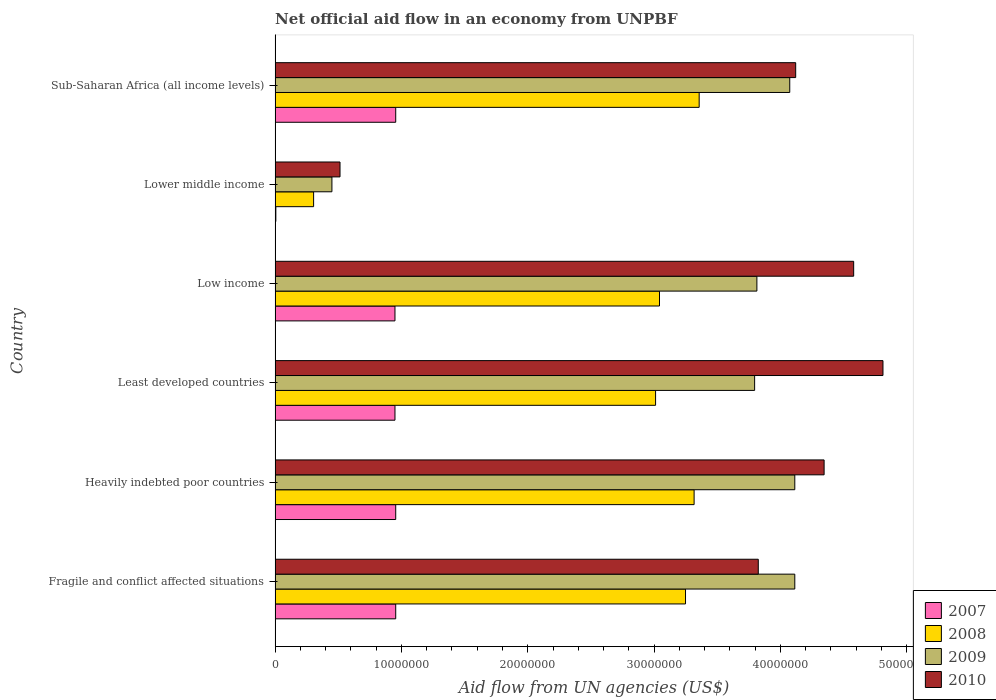Are the number of bars per tick equal to the number of legend labels?
Offer a very short reply. Yes. How many bars are there on the 6th tick from the bottom?
Keep it short and to the point. 4. What is the label of the 3rd group of bars from the top?
Provide a succinct answer. Low income. What is the net official aid flow in 2008 in Low income?
Make the answer very short. 3.04e+07. Across all countries, what is the maximum net official aid flow in 2008?
Give a very brief answer. 3.36e+07. Across all countries, what is the minimum net official aid flow in 2008?
Offer a very short reply. 3.05e+06. In which country was the net official aid flow in 2010 maximum?
Keep it short and to the point. Least developed countries. In which country was the net official aid flow in 2007 minimum?
Offer a terse response. Lower middle income. What is the total net official aid flow in 2009 in the graph?
Give a very brief answer. 2.04e+08. What is the difference between the net official aid flow in 2008 in Lower middle income and that in Sub-Saharan Africa (all income levels)?
Your answer should be compact. -3.05e+07. What is the difference between the net official aid flow in 2009 in Sub-Saharan Africa (all income levels) and the net official aid flow in 2008 in Low income?
Keep it short and to the point. 1.03e+07. What is the average net official aid flow in 2009 per country?
Offer a very short reply. 3.39e+07. What is the difference between the net official aid flow in 2010 and net official aid flow in 2007 in Low income?
Provide a succinct answer. 3.63e+07. In how many countries, is the net official aid flow in 2009 greater than 24000000 US$?
Provide a succinct answer. 5. What is the ratio of the net official aid flow in 2007 in Fragile and conflict affected situations to that in Low income?
Provide a succinct answer. 1.01. Is the net official aid flow in 2008 in Fragile and conflict affected situations less than that in Sub-Saharan Africa (all income levels)?
Give a very brief answer. Yes. Is the difference between the net official aid flow in 2010 in Heavily indebted poor countries and Sub-Saharan Africa (all income levels) greater than the difference between the net official aid flow in 2007 in Heavily indebted poor countries and Sub-Saharan Africa (all income levels)?
Your answer should be compact. Yes. What is the difference between the highest and the lowest net official aid flow in 2008?
Your answer should be compact. 3.05e+07. In how many countries, is the net official aid flow in 2007 greater than the average net official aid flow in 2007 taken over all countries?
Give a very brief answer. 5. What is the difference between two consecutive major ticks on the X-axis?
Keep it short and to the point. 1.00e+07. Are the values on the major ticks of X-axis written in scientific E-notation?
Make the answer very short. No. Where does the legend appear in the graph?
Your response must be concise. Bottom right. How many legend labels are there?
Ensure brevity in your answer.  4. How are the legend labels stacked?
Offer a very short reply. Vertical. What is the title of the graph?
Provide a succinct answer. Net official aid flow in an economy from UNPBF. What is the label or title of the X-axis?
Ensure brevity in your answer.  Aid flow from UN agencies (US$). What is the label or title of the Y-axis?
Ensure brevity in your answer.  Country. What is the Aid flow from UN agencies (US$) in 2007 in Fragile and conflict affected situations?
Provide a short and direct response. 9.55e+06. What is the Aid flow from UN agencies (US$) in 2008 in Fragile and conflict affected situations?
Keep it short and to the point. 3.25e+07. What is the Aid flow from UN agencies (US$) of 2009 in Fragile and conflict affected situations?
Ensure brevity in your answer.  4.11e+07. What is the Aid flow from UN agencies (US$) in 2010 in Fragile and conflict affected situations?
Provide a short and direct response. 3.82e+07. What is the Aid flow from UN agencies (US$) in 2007 in Heavily indebted poor countries?
Keep it short and to the point. 9.55e+06. What is the Aid flow from UN agencies (US$) in 2008 in Heavily indebted poor countries?
Make the answer very short. 3.32e+07. What is the Aid flow from UN agencies (US$) in 2009 in Heavily indebted poor countries?
Provide a short and direct response. 4.11e+07. What is the Aid flow from UN agencies (US$) of 2010 in Heavily indebted poor countries?
Keep it short and to the point. 4.35e+07. What is the Aid flow from UN agencies (US$) of 2007 in Least developed countries?
Ensure brevity in your answer.  9.49e+06. What is the Aid flow from UN agencies (US$) in 2008 in Least developed countries?
Your response must be concise. 3.01e+07. What is the Aid flow from UN agencies (US$) in 2009 in Least developed countries?
Keep it short and to the point. 3.80e+07. What is the Aid flow from UN agencies (US$) in 2010 in Least developed countries?
Your answer should be compact. 4.81e+07. What is the Aid flow from UN agencies (US$) in 2007 in Low income?
Keep it short and to the point. 9.49e+06. What is the Aid flow from UN agencies (US$) in 2008 in Low income?
Your response must be concise. 3.04e+07. What is the Aid flow from UN agencies (US$) in 2009 in Low income?
Make the answer very short. 3.81e+07. What is the Aid flow from UN agencies (US$) of 2010 in Low income?
Ensure brevity in your answer.  4.58e+07. What is the Aid flow from UN agencies (US$) in 2008 in Lower middle income?
Give a very brief answer. 3.05e+06. What is the Aid flow from UN agencies (US$) in 2009 in Lower middle income?
Offer a very short reply. 4.50e+06. What is the Aid flow from UN agencies (US$) in 2010 in Lower middle income?
Your response must be concise. 5.14e+06. What is the Aid flow from UN agencies (US$) of 2007 in Sub-Saharan Africa (all income levels)?
Ensure brevity in your answer.  9.55e+06. What is the Aid flow from UN agencies (US$) in 2008 in Sub-Saharan Africa (all income levels)?
Offer a very short reply. 3.36e+07. What is the Aid flow from UN agencies (US$) in 2009 in Sub-Saharan Africa (all income levels)?
Your answer should be compact. 4.07e+07. What is the Aid flow from UN agencies (US$) in 2010 in Sub-Saharan Africa (all income levels)?
Ensure brevity in your answer.  4.12e+07. Across all countries, what is the maximum Aid flow from UN agencies (US$) of 2007?
Offer a very short reply. 9.55e+06. Across all countries, what is the maximum Aid flow from UN agencies (US$) in 2008?
Offer a very short reply. 3.36e+07. Across all countries, what is the maximum Aid flow from UN agencies (US$) in 2009?
Give a very brief answer. 4.11e+07. Across all countries, what is the maximum Aid flow from UN agencies (US$) in 2010?
Your answer should be very brief. 4.81e+07. Across all countries, what is the minimum Aid flow from UN agencies (US$) in 2008?
Ensure brevity in your answer.  3.05e+06. Across all countries, what is the minimum Aid flow from UN agencies (US$) of 2009?
Keep it short and to the point. 4.50e+06. Across all countries, what is the minimum Aid flow from UN agencies (US$) of 2010?
Provide a short and direct response. 5.14e+06. What is the total Aid flow from UN agencies (US$) of 2007 in the graph?
Make the answer very short. 4.77e+07. What is the total Aid flow from UN agencies (US$) of 2008 in the graph?
Your response must be concise. 1.63e+08. What is the total Aid flow from UN agencies (US$) in 2009 in the graph?
Offer a terse response. 2.04e+08. What is the total Aid flow from UN agencies (US$) of 2010 in the graph?
Provide a succinct answer. 2.22e+08. What is the difference between the Aid flow from UN agencies (US$) in 2007 in Fragile and conflict affected situations and that in Heavily indebted poor countries?
Provide a short and direct response. 0. What is the difference between the Aid flow from UN agencies (US$) of 2008 in Fragile and conflict affected situations and that in Heavily indebted poor countries?
Give a very brief answer. -6.80e+05. What is the difference between the Aid flow from UN agencies (US$) in 2010 in Fragile and conflict affected situations and that in Heavily indebted poor countries?
Provide a short and direct response. -5.21e+06. What is the difference between the Aid flow from UN agencies (US$) in 2007 in Fragile and conflict affected situations and that in Least developed countries?
Your answer should be compact. 6.00e+04. What is the difference between the Aid flow from UN agencies (US$) in 2008 in Fragile and conflict affected situations and that in Least developed countries?
Offer a terse response. 2.37e+06. What is the difference between the Aid flow from UN agencies (US$) in 2009 in Fragile and conflict affected situations and that in Least developed countries?
Your answer should be compact. 3.18e+06. What is the difference between the Aid flow from UN agencies (US$) in 2010 in Fragile and conflict affected situations and that in Least developed countries?
Keep it short and to the point. -9.87e+06. What is the difference between the Aid flow from UN agencies (US$) in 2008 in Fragile and conflict affected situations and that in Low income?
Your answer should be compact. 2.06e+06. What is the difference between the Aid flow from UN agencies (US$) in 2010 in Fragile and conflict affected situations and that in Low income?
Offer a terse response. -7.55e+06. What is the difference between the Aid flow from UN agencies (US$) in 2007 in Fragile and conflict affected situations and that in Lower middle income?
Offer a terse response. 9.49e+06. What is the difference between the Aid flow from UN agencies (US$) in 2008 in Fragile and conflict affected situations and that in Lower middle income?
Give a very brief answer. 2.94e+07. What is the difference between the Aid flow from UN agencies (US$) in 2009 in Fragile and conflict affected situations and that in Lower middle income?
Give a very brief answer. 3.66e+07. What is the difference between the Aid flow from UN agencies (US$) of 2010 in Fragile and conflict affected situations and that in Lower middle income?
Provide a short and direct response. 3.31e+07. What is the difference between the Aid flow from UN agencies (US$) of 2007 in Fragile and conflict affected situations and that in Sub-Saharan Africa (all income levels)?
Ensure brevity in your answer.  0. What is the difference between the Aid flow from UN agencies (US$) of 2008 in Fragile and conflict affected situations and that in Sub-Saharan Africa (all income levels)?
Your response must be concise. -1.08e+06. What is the difference between the Aid flow from UN agencies (US$) in 2010 in Fragile and conflict affected situations and that in Sub-Saharan Africa (all income levels)?
Keep it short and to the point. -2.96e+06. What is the difference between the Aid flow from UN agencies (US$) in 2008 in Heavily indebted poor countries and that in Least developed countries?
Ensure brevity in your answer.  3.05e+06. What is the difference between the Aid flow from UN agencies (US$) in 2009 in Heavily indebted poor countries and that in Least developed countries?
Your response must be concise. 3.18e+06. What is the difference between the Aid flow from UN agencies (US$) in 2010 in Heavily indebted poor countries and that in Least developed countries?
Provide a succinct answer. -4.66e+06. What is the difference between the Aid flow from UN agencies (US$) of 2008 in Heavily indebted poor countries and that in Low income?
Offer a terse response. 2.74e+06. What is the difference between the Aid flow from UN agencies (US$) in 2010 in Heavily indebted poor countries and that in Low income?
Make the answer very short. -2.34e+06. What is the difference between the Aid flow from UN agencies (US$) in 2007 in Heavily indebted poor countries and that in Lower middle income?
Provide a succinct answer. 9.49e+06. What is the difference between the Aid flow from UN agencies (US$) in 2008 in Heavily indebted poor countries and that in Lower middle income?
Your answer should be compact. 3.01e+07. What is the difference between the Aid flow from UN agencies (US$) in 2009 in Heavily indebted poor countries and that in Lower middle income?
Ensure brevity in your answer.  3.66e+07. What is the difference between the Aid flow from UN agencies (US$) in 2010 in Heavily indebted poor countries and that in Lower middle income?
Your response must be concise. 3.83e+07. What is the difference between the Aid flow from UN agencies (US$) in 2007 in Heavily indebted poor countries and that in Sub-Saharan Africa (all income levels)?
Provide a short and direct response. 0. What is the difference between the Aid flow from UN agencies (US$) of 2008 in Heavily indebted poor countries and that in Sub-Saharan Africa (all income levels)?
Your response must be concise. -4.00e+05. What is the difference between the Aid flow from UN agencies (US$) of 2009 in Heavily indebted poor countries and that in Sub-Saharan Africa (all income levels)?
Keep it short and to the point. 4.00e+05. What is the difference between the Aid flow from UN agencies (US$) of 2010 in Heavily indebted poor countries and that in Sub-Saharan Africa (all income levels)?
Offer a very short reply. 2.25e+06. What is the difference between the Aid flow from UN agencies (US$) of 2008 in Least developed countries and that in Low income?
Your answer should be compact. -3.10e+05. What is the difference between the Aid flow from UN agencies (US$) of 2009 in Least developed countries and that in Low income?
Provide a succinct answer. -1.80e+05. What is the difference between the Aid flow from UN agencies (US$) in 2010 in Least developed countries and that in Low income?
Your response must be concise. 2.32e+06. What is the difference between the Aid flow from UN agencies (US$) in 2007 in Least developed countries and that in Lower middle income?
Ensure brevity in your answer.  9.43e+06. What is the difference between the Aid flow from UN agencies (US$) of 2008 in Least developed countries and that in Lower middle income?
Ensure brevity in your answer.  2.71e+07. What is the difference between the Aid flow from UN agencies (US$) in 2009 in Least developed countries and that in Lower middle income?
Offer a terse response. 3.35e+07. What is the difference between the Aid flow from UN agencies (US$) in 2010 in Least developed countries and that in Lower middle income?
Offer a terse response. 4.30e+07. What is the difference between the Aid flow from UN agencies (US$) in 2008 in Least developed countries and that in Sub-Saharan Africa (all income levels)?
Offer a very short reply. -3.45e+06. What is the difference between the Aid flow from UN agencies (US$) in 2009 in Least developed countries and that in Sub-Saharan Africa (all income levels)?
Ensure brevity in your answer.  -2.78e+06. What is the difference between the Aid flow from UN agencies (US$) of 2010 in Least developed countries and that in Sub-Saharan Africa (all income levels)?
Your answer should be very brief. 6.91e+06. What is the difference between the Aid flow from UN agencies (US$) of 2007 in Low income and that in Lower middle income?
Offer a very short reply. 9.43e+06. What is the difference between the Aid flow from UN agencies (US$) of 2008 in Low income and that in Lower middle income?
Provide a short and direct response. 2.74e+07. What is the difference between the Aid flow from UN agencies (US$) in 2009 in Low income and that in Lower middle income?
Offer a terse response. 3.36e+07. What is the difference between the Aid flow from UN agencies (US$) in 2010 in Low income and that in Lower middle income?
Make the answer very short. 4.07e+07. What is the difference between the Aid flow from UN agencies (US$) in 2008 in Low income and that in Sub-Saharan Africa (all income levels)?
Your answer should be very brief. -3.14e+06. What is the difference between the Aid flow from UN agencies (US$) in 2009 in Low income and that in Sub-Saharan Africa (all income levels)?
Your answer should be compact. -2.60e+06. What is the difference between the Aid flow from UN agencies (US$) in 2010 in Low income and that in Sub-Saharan Africa (all income levels)?
Provide a succinct answer. 4.59e+06. What is the difference between the Aid flow from UN agencies (US$) in 2007 in Lower middle income and that in Sub-Saharan Africa (all income levels)?
Your answer should be compact. -9.49e+06. What is the difference between the Aid flow from UN agencies (US$) in 2008 in Lower middle income and that in Sub-Saharan Africa (all income levels)?
Keep it short and to the point. -3.05e+07. What is the difference between the Aid flow from UN agencies (US$) of 2009 in Lower middle income and that in Sub-Saharan Africa (all income levels)?
Make the answer very short. -3.62e+07. What is the difference between the Aid flow from UN agencies (US$) of 2010 in Lower middle income and that in Sub-Saharan Africa (all income levels)?
Your response must be concise. -3.61e+07. What is the difference between the Aid flow from UN agencies (US$) of 2007 in Fragile and conflict affected situations and the Aid flow from UN agencies (US$) of 2008 in Heavily indebted poor countries?
Offer a very short reply. -2.36e+07. What is the difference between the Aid flow from UN agencies (US$) of 2007 in Fragile and conflict affected situations and the Aid flow from UN agencies (US$) of 2009 in Heavily indebted poor countries?
Give a very brief answer. -3.16e+07. What is the difference between the Aid flow from UN agencies (US$) in 2007 in Fragile and conflict affected situations and the Aid flow from UN agencies (US$) in 2010 in Heavily indebted poor countries?
Keep it short and to the point. -3.39e+07. What is the difference between the Aid flow from UN agencies (US$) in 2008 in Fragile and conflict affected situations and the Aid flow from UN agencies (US$) in 2009 in Heavily indebted poor countries?
Your response must be concise. -8.65e+06. What is the difference between the Aid flow from UN agencies (US$) of 2008 in Fragile and conflict affected situations and the Aid flow from UN agencies (US$) of 2010 in Heavily indebted poor countries?
Ensure brevity in your answer.  -1.10e+07. What is the difference between the Aid flow from UN agencies (US$) of 2009 in Fragile and conflict affected situations and the Aid flow from UN agencies (US$) of 2010 in Heavily indebted poor countries?
Your answer should be very brief. -2.32e+06. What is the difference between the Aid flow from UN agencies (US$) in 2007 in Fragile and conflict affected situations and the Aid flow from UN agencies (US$) in 2008 in Least developed countries?
Provide a succinct answer. -2.06e+07. What is the difference between the Aid flow from UN agencies (US$) in 2007 in Fragile and conflict affected situations and the Aid flow from UN agencies (US$) in 2009 in Least developed countries?
Your answer should be very brief. -2.84e+07. What is the difference between the Aid flow from UN agencies (US$) of 2007 in Fragile and conflict affected situations and the Aid flow from UN agencies (US$) of 2010 in Least developed countries?
Offer a terse response. -3.86e+07. What is the difference between the Aid flow from UN agencies (US$) of 2008 in Fragile and conflict affected situations and the Aid flow from UN agencies (US$) of 2009 in Least developed countries?
Offer a very short reply. -5.47e+06. What is the difference between the Aid flow from UN agencies (US$) of 2008 in Fragile and conflict affected situations and the Aid flow from UN agencies (US$) of 2010 in Least developed countries?
Keep it short and to the point. -1.56e+07. What is the difference between the Aid flow from UN agencies (US$) of 2009 in Fragile and conflict affected situations and the Aid flow from UN agencies (US$) of 2010 in Least developed countries?
Your response must be concise. -6.98e+06. What is the difference between the Aid flow from UN agencies (US$) of 2007 in Fragile and conflict affected situations and the Aid flow from UN agencies (US$) of 2008 in Low income?
Keep it short and to the point. -2.09e+07. What is the difference between the Aid flow from UN agencies (US$) of 2007 in Fragile and conflict affected situations and the Aid flow from UN agencies (US$) of 2009 in Low income?
Offer a terse response. -2.86e+07. What is the difference between the Aid flow from UN agencies (US$) in 2007 in Fragile and conflict affected situations and the Aid flow from UN agencies (US$) in 2010 in Low income?
Your answer should be very brief. -3.62e+07. What is the difference between the Aid flow from UN agencies (US$) of 2008 in Fragile and conflict affected situations and the Aid flow from UN agencies (US$) of 2009 in Low income?
Provide a short and direct response. -5.65e+06. What is the difference between the Aid flow from UN agencies (US$) of 2008 in Fragile and conflict affected situations and the Aid flow from UN agencies (US$) of 2010 in Low income?
Your answer should be compact. -1.33e+07. What is the difference between the Aid flow from UN agencies (US$) in 2009 in Fragile and conflict affected situations and the Aid flow from UN agencies (US$) in 2010 in Low income?
Ensure brevity in your answer.  -4.66e+06. What is the difference between the Aid flow from UN agencies (US$) in 2007 in Fragile and conflict affected situations and the Aid flow from UN agencies (US$) in 2008 in Lower middle income?
Keep it short and to the point. 6.50e+06. What is the difference between the Aid flow from UN agencies (US$) of 2007 in Fragile and conflict affected situations and the Aid flow from UN agencies (US$) of 2009 in Lower middle income?
Ensure brevity in your answer.  5.05e+06. What is the difference between the Aid flow from UN agencies (US$) in 2007 in Fragile and conflict affected situations and the Aid flow from UN agencies (US$) in 2010 in Lower middle income?
Keep it short and to the point. 4.41e+06. What is the difference between the Aid flow from UN agencies (US$) in 2008 in Fragile and conflict affected situations and the Aid flow from UN agencies (US$) in 2009 in Lower middle income?
Offer a terse response. 2.80e+07. What is the difference between the Aid flow from UN agencies (US$) of 2008 in Fragile and conflict affected situations and the Aid flow from UN agencies (US$) of 2010 in Lower middle income?
Keep it short and to the point. 2.74e+07. What is the difference between the Aid flow from UN agencies (US$) of 2009 in Fragile and conflict affected situations and the Aid flow from UN agencies (US$) of 2010 in Lower middle income?
Your answer should be very brief. 3.60e+07. What is the difference between the Aid flow from UN agencies (US$) of 2007 in Fragile and conflict affected situations and the Aid flow from UN agencies (US$) of 2008 in Sub-Saharan Africa (all income levels)?
Make the answer very short. -2.40e+07. What is the difference between the Aid flow from UN agencies (US$) in 2007 in Fragile and conflict affected situations and the Aid flow from UN agencies (US$) in 2009 in Sub-Saharan Africa (all income levels)?
Your response must be concise. -3.12e+07. What is the difference between the Aid flow from UN agencies (US$) of 2007 in Fragile and conflict affected situations and the Aid flow from UN agencies (US$) of 2010 in Sub-Saharan Africa (all income levels)?
Make the answer very short. -3.17e+07. What is the difference between the Aid flow from UN agencies (US$) of 2008 in Fragile and conflict affected situations and the Aid flow from UN agencies (US$) of 2009 in Sub-Saharan Africa (all income levels)?
Ensure brevity in your answer.  -8.25e+06. What is the difference between the Aid flow from UN agencies (US$) in 2008 in Fragile and conflict affected situations and the Aid flow from UN agencies (US$) in 2010 in Sub-Saharan Africa (all income levels)?
Provide a succinct answer. -8.72e+06. What is the difference between the Aid flow from UN agencies (US$) of 2007 in Heavily indebted poor countries and the Aid flow from UN agencies (US$) of 2008 in Least developed countries?
Offer a terse response. -2.06e+07. What is the difference between the Aid flow from UN agencies (US$) of 2007 in Heavily indebted poor countries and the Aid flow from UN agencies (US$) of 2009 in Least developed countries?
Your answer should be compact. -2.84e+07. What is the difference between the Aid flow from UN agencies (US$) of 2007 in Heavily indebted poor countries and the Aid flow from UN agencies (US$) of 2010 in Least developed countries?
Offer a terse response. -3.86e+07. What is the difference between the Aid flow from UN agencies (US$) of 2008 in Heavily indebted poor countries and the Aid flow from UN agencies (US$) of 2009 in Least developed countries?
Provide a short and direct response. -4.79e+06. What is the difference between the Aid flow from UN agencies (US$) in 2008 in Heavily indebted poor countries and the Aid flow from UN agencies (US$) in 2010 in Least developed countries?
Provide a short and direct response. -1.50e+07. What is the difference between the Aid flow from UN agencies (US$) of 2009 in Heavily indebted poor countries and the Aid flow from UN agencies (US$) of 2010 in Least developed countries?
Make the answer very short. -6.98e+06. What is the difference between the Aid flow from UN agencies (US$) in 2007 in Heavily indebted poor countries and the Aid flow from UN agencies (US$) in 2008 in Low income?
Give a very brief answer. -2.09e+07. What is the difference between the Aid flow from UN agencies (US$) of 2007 in Heavily indebted poor countries and the Aid flow from UN agencies (US$) of 2009 in Low income?
Make the answer very short. -2.86e+07. What is the difference between the Aid flow from UN agencies (US$) in 2007 in Heavily indebted poor countries and the Aid flow from UN agencies (US$) in 2010 in Low income?
Your answer should be very brief. -3.62e+07. What is the difference between the Aid flow from UN agencies (US$) of 2008 in Heavily indebted poor countries and the Aid flow from UN agencies (US$) of 2009 in Low income?
Provide a succinct answer. -4.97e+06. What is the difference between the Aid flow from UN agencies (US$) in 2008 in Heavily indebted poor countries and the Aid flow from UN agencies (US$) in 2010 in Low income?
Offer a very short reply. -1.26e+07. What is the difference between the Aid flow from UN agencies (US$) of 2009 in Heavily indebted poor countries and the Aid flow from UN agencies (US$) of 2010 in Low income?
Keep it short and to the point. -4.66e+06. What is the difference between the Aid flow from UN agencies (US$) in 2007 in Heavily indebted poor countries and the Aid flow from UN agencies (US$) in 2008 in Lower middle income?
Your answer should be very brief. 6.50e+06. What is the difference between the Aid flow from UN agencies (US$) of 2007 in Heavily indebted poor countries and the Aid flow from UN agencies (US$) of 2009 in Lower middle income?
Ensure brevity in your answer.  5.05e+06. What is the difference between the Aid flow from UN agencies (US$) of 2007 in Heavily indebted poor countries and the Aid flow from UN agencies (US$) of 2010 in Lower middle income?
Keep it short and to the point. 4.41e+06. What is the difference between the Aid flow from UN agencies (US$) of 2008 in Heavily indebted poor countries and the Aid flow from UN agencies (US$) of 2009 in Lower middle income?
Your response must be concise. 2.87e+07. What is the difference between the Aid flow from UN agencies (US$) in 2008 in Heavily indebted poor countries and the Aid flow from UN agencies (US$) in 2010 in Lower middle income?
Provide a succinct answer. 2.80e+07. What is the difference between the Aid flow from UN agencies (US$) of 2009 in Heavily indebted poor countries and the Aid flow from UN agencies (US$) of 2010 in Lower middle income?
Offer a very short reply. 3.60e+07. What is the difference between the Aid flow from UN agencies (US$) in 2007 in Heavily indebted poor countries and the Aid flow from UN agencies (US$) in 2008 in Sub-Saharan Africa (all income levels)?
Ensure brevity in your answer.  -2.40e+07. What is the difference between the Aid flow from UN agencies (US$) of 2007 in Heavily indebted poor countries and the Aid flow from UN agencies (US$) of 2009 in Sub-Saharan Africa (all income levels)?
Make the answer very short. -3.12e+07. What is the difference between the Aid flow from UN agencies (US$) of 2007 in Heavily indebted poor countries and the Aid flow from UN agencies (US$) of 2010 in Sub-Saharan Africa (all income levels)?
Offer a very short reply. -3.17e+07. What is the difference between the Aid flow from UN agencies (US$) in 2008 in Heavily indebted poor countries and the Aid flow from UN agencies (US$) in 2009 in Sub-Saharan Africa (all income levels)?
Provide a short and direct response. -7.57e+06. What is the difference between the Aid flow from UN agencies (US$) in 2008 in Heavily indebted poor countries and the Aid flow from UN agencies (US$) in 2010 in Sub-Saharan Africa (all income levels)?
Ensure brevity in your answer.  -8.04e+06. What is the difference between the Aid flow from UN agencies (US$) in 2007 in Least developed countries and the Aid flow from UN agencies (US$) in 2008 in Low income?
Keep it short and to the point. -2.09e+07. What is the difference between the Aid flow from UN agencies (US$) in 2007 in Least developed countries and the Aid flow from UN agencies (US$) in 2009 in Low income?
Provide a succinct answer. -2.86e+07. What is the difference between the Aid flow from UN agencies (US$) in 2007 in Least developed countries and the Aid flow from UN agencies (US$) in 2010 in Low income?
Your response must be concise. -3.63e+07. What is the difference between the Aid flow from UN agencies (US$) in 2008 in Least developed countries and the Aid flow from UN agencies (US$) in 2009 in Low income?
Provide a short and direct response. -8.02e+06. What is the difference between the Aid flow from UN agencies (US$) in 2008 in Least developed countries and the Aid flow from UN agencies (US$) in 2010 in Low income?
Your answer should be compact. -1.57e+07. What is the difference between the Aid flow from UN agencies (US$) of 2009 in Least developed countries and the Aid flow from UN agencies (US$) of 2010 in Low income?
Offer a very short reply. -7.84e+06. What is the difference between the Aid flow from UN agencies (US$) of 2007 in Least developed countries and the Aid flow from UN agencies (US$) of 2008 in Lower middle income?
Your response must be concise. 6.44e+06. What is the difference between the Aid flow from UN agencies (US$) in 2007 in Least developed countries and the Aid flow from UN agencies (US$) in 2009 in Lower middle income?
Your answer should be very brief. 4.99e+06. What is the difference between the Aid flow from UN agencies (US$) in 2007 in Least developed countries and the Aid flow from UN agencies (US$) in 2010 in Lower middle income?
Offer a terse response. 4.35e+06. What is the difference between the Aid flow from UN agencies (US$) in 2008 in Least developed countries and the Aid flow from UN agencies (US$) in 2009 in Lower middle income?
Ensure brevity in your answer.  2.56e+07. What is the difference between the Aid flow from UN agencies (US$) of 2008 in Least developed countries and the Aid flow from UN agencies (US$) of 2010 in Lower middle income?
Make the answer very short. 2.50e+07. What is the difference between the Aid flow from UN agencies (US$) of 2009 in Least developed countries and the Aid flow from UN agencies (US$) of 2010 in Lower middle income?
Keep it short and to the point. 3.28e+07. What is the difference between the Aid flow from UN agencies (US$) of 2007 in Least developed countries and the Aid flow from UN agencies (US$) of 2008 in Sub-Saharan Africa (all income levels)?
Ensure brevity in your answer.  -2.41e+07. What is the difference between the Aid flow from UN agencies (US$) in 2007 in Least developed countries and the Aid flow from UN agencies (US$) in 2009 in Sub-Saharan Africa (all income levels)?
Your response must be concise. -3.12e+07. What is the difference between the Aid flow from UN agencies (US$) of 2007 in Least developed countries and the Aid flow from UN agencies (US$) of 2010 in Sub-Saharan Africa (all income levels)?
Your response must be concise. -3.17e+07. What is the difference between the Aid flow from UN agencies (US$) in 2008 in Least developed countries and the Aid flow from UN agencies (US$) in 2009 in Sub-Saharan Africa (all income levels)?
Make the answer very short. -1.06e+07. What is the difference between the Aid flow from UN agencies (US$) of 2008 in Least developed countries and the Aid flow from UN agencies (US$) of 2010 in Sub-Saharan Africa (all income levels)?
Provide a short and direct response. -1.11e+07. What is the difference between the Aid flow from UN agencies (US$) in 2009 in Least developed countries and the Aid flow from UN agencies (US$) in 2010 in Sub-Saharan Africa (all income levels)?
Your answer should be compact. -3.25e+06. What is the difference between the Aid flow from UN agencies (US$) in 2007 in Low income and the Aid flow from UN agencies (US$) in 2008 in Lower middle income?
Provide a short and direct response. 6.44e+06. What is the difference between the Aid flow from UN agencies (US$) in 2007 in Low income and the Aid flow from UN agencies (US$) in 2009 in Lower middle income?
Give a very brief answer. 4.99e+06. What is the difference between the Aid flow from UN agencies (US$) of 2007 in Low income and the Aid flow from UN agencies (US$) of 2010 in Lower middle income?
Your answer should be compact. 4.35e+06. What is the difference between the Aid flow from UN agencies (US$) of 2008 in Low income and the Aid flow from UN agencies (US$) of 2009 in Lower middle income?
Provide a short and direct response. 2.59e+07. What is the difference between the Aid flow from UN agencies (US$) in 2008 in Low income and the Aid flow from UN agencies (US$) in 2010 in Lower middle income?
Provide a succinct answer. 2.53e+07. What is the difference between the Aid flow from UN agencies (US$) of 2009 in Low income and the Aid flow from UN agencies (US$) of 2010 in Lower middle income?
Provide a succinct answer. 3.30e+07. What is the difference between the Aid flow from UN agencies (US$) in 2007 in Low income and the Aid flow from UN agencies (US$) in 2008 in Sub-Saharan Africa (all income levels)?
Offer a very short reply. -2.41e+07. What is the difference between the Aid flow from UN agencies (US$) of 2007 in Low income and the Aid flow from UN agencies (US$) of 2009 in Sub-Saharan Africa (all income levels)?
Provide a succinct answer. -3.12e+07. What is the difference between the Aid flow from UN agencies (US$) of 2007 in Low income and the Aid flow from UN agencies (US$) of 2010 in Sub-Saharan Africa (all income levels)?
Give a very brief answer. -3.17e+07. What is the difference between the Aid flow from UN agencies (US$) of 2008 in Low income and the Aid flow from UN agencies (US$) of 2009 in Sub-Saharan Africa (all income levels)?
Your answer should be very brief. -1.03e+07. What is the difference between the Aid flow from UN agencies (US$) of 2008 in Low income and the Aid flow from UN agencies (US$) of 2010 in Sub-Saharan Africa (all income levels)?
Offer a terse response. -1.08e+07. What is the difference between the Aid flow from UN agencies (US$) of 2009 in Low income and the Aid flow from UN agencies (US$) of 2010 in Sub-Saharan Africa (all income levels)?
Offer a terse response. -3.07e+06. What is the difference between the Aid flow from UN agencies (US$) in 2007 in Lower middle income and the Aid flow from UN agencies (US$) in 2008 in Sub-Saharan Africa (all income levels)?
Keep it short and to the point. -3.35e+07. What is the difference between the Aid flow from UN agencies (US$) of 2007 in Lower middle income and the Aid flow from UN agencies (US$) of 2009 in Sub-Saharan Africa (all income levels)?
Provide a succinct answer. -4.07e+07. What is the difference between the Aid flow from UN agencies (US$) of 2007 in Lower middle income and the Aid flow from UN agencies (US$) of 2010 in Sub-Saharan Africa (all income levels)?
Your answer should be very brief. -4.12e+07. What is the difference between the Aid flow from UN agencies (US$) of 2008 in Lower middle income and the Aid flow from UN agencies (US$) of 2009 in Sub-Saharan Africa (all income levels)?
Provide a succinct answer. -3.77e+07. What is the difference between the Aid flow from UN agencies (US$) of 2008 in Lower middle income and the Aid flow from UN agencies (US$) of 2010 in Sub-Saharan Africa (all income levels)?
Give a very brief answer. -3.82e+07. What is the difference between the Aid flow from UN agencies (US$) of 2009 in Lower middle income and the Aid flow from UN agencies (US$) of 2010 in Sub-Saharan Africa (all income levels)?
Ensure brevity in your answer.  -3.67e+07. What is the average Aid flow from UN agencies (US$) in 2007 per country?
Provide a short and direct response. 7.95e+06. What is the average Aid flow from UN agencies (US$) in 2008 per country?
Provide a succinct answer. 2.71e+07. What is the average Aid flow from UN agencies (US$) in 2009 per country?
Offer a terse response. 3.39e+07. What is the average Aid flow from UN agencies (US$) in 2010 per country?
Make the answer very short. 3.70e+07. What is the difference between the Aid flow from UN agencies (US$) in 2007 and Aid flow from UN agencies (US$) in 2008 in Fragile and conflict affected situations?
Make the answer very short. -2.29e+07. What is the difference between the Aid flow from UN agencies (US$) in 2007 and Aid flow from UN agencies (US$) in 2009 in Fragile and conflict affected situations?
Ensure brevity in your answer.  -3.16e+07. What is the difference between the Aid flow from UN agencies (US$) of 2007 and Aid flow from UN agencies (US$) of 2010 in Fragile and conflict affected situations?
Offer a very short reply. -2.87e+07. What is the difference between the Aid flow from UN agencies (US$) in 2008 and Aid flow from UN agencies (US$) in 2009 in Fragile and conflict affected situations?
Your response must be concise. -8.65e+06. What is the difference between the Aid flow from UN agencies (US$) of 2008 and Aid flow from UN agencies (US$) of 2010 in Fragile and conflict affected situations?
Keep it short and to the point. -5.76e+06. What is the difference between the Aid flow from UN agencies (US$) of 2009 and Aid flow from UN agencies (US$) of 2010 in Fragile and conflict affected situations?
Keep it short and to the point. 2.89e+06. What is the difference between the Aid flow from UN agencies (US$) of 2007 and Aid flow from UN agencies (US$) of 2008 in Heavily indebted poor countries?
Your response must be concise. -2.36e+07. What is the difference between the Aid flow from UN agencies (US$) in 2007 and Aid flow from UN agencies (US$) in 2009 in Heavily indebted poor countries?
Give a very brief answer. -3.16e+07. What is the difference between the Aid flow from UN agencies (US$) of 2007 and Aid flow from UN agencies (US$) of 2010 in Heavily indebted poor countries?
Provide a succinct answer. -3.39e+07. What is the difference between the Aid flow from UN agencies (US$) in 2008 and Aid flow from UN agencies (US$) in 2009 in Heavily indebted poor countries?
Your answer should be compact. -7.97e+06. What is the difference between the Aid flow from UN agencies (US$) of 2008 and Aid flow from UN agencies (US$) of 2010 in Heavily indebted poor countries?
Keep it short and to the point. -1.03e+07. What is the difference between the Aid flow from UN agencies (US$) in 2009 and Aid flow from UN agencies (US$) in 2010 in Heavily indebted poor countries?
Give a very brief answer. -2.32e+06. What is the difference between the Aid flow from UN agencies (US$) in 2007 and Aid flow from UN agencies (US$) in 2008 in Least developed countries?
Give a very brief answer. -2.06e+07. What is the difference between the Aid flow from UN agencies (US$) in 2007 and Aid flow from UN agencies (US$) in 2009 in Least developed countries?
Offer a very short reply. -2.85e+07. What is the difference between the Aid flow from UN agencies (US$) of 2007 and Aid flow from UN agencies (US$) of 2010 in Least developed countries?
Your response must be concise. -3.86e+07. What is the difference between the Aid flow from UN agencies (US$) of 2008 and Aid flow from UN agencies (US$) of 2009 in Least developed countries?
Your answer should be compact. -7.84e+06. What is the difference between the Aid flow from UN agencies (US$) in 2008 and Aid flow from UN agencies (US$) in 2010 in Least developed countries?
Provide a succinct answer. -1.80e+07. What is the difference between the Aid flow from UN agencies (US$) of 2009 and Aid flow from UN agencies (US$) of 2010 in Least developed countries?
Offer a very short reply. -1.02e+07. What is the difference between the Aid flow from UN agencies (US$) of 2007 and Aid flow from UN agencies (US$) of 2008 in Low income?
Provide a succinct answer. -2.09e+07. What is the difference between the Aid flow from UN agencies (US$) of 2007 and Aid flow from UN agencies (US$) of 2009 in Low income?
Provide a short and direct response. -2.86e+07. What is the difference between the Aid flow from UN agencies (US$) in 2007 and Aid flow from UN agencies (US$) in 2010 in Low income?
Offer a very short reply. -3.63e+07. What is the difference between the Aid flow from UN agencies (US$) of 2008 and Aid flow from UN agencies (US$) of 2009 in Low income?
Offer a terse response. -7.71e+06. What is the difference between the Aid flow from UN agencies (US$) of 2008 and Aid flow from UN agencies (US$) of 2010 in Low income?
Offer a terse response. -1.54e+07. What is the difference between the Aid flow from UN agencies (US$) of 2009 and Aid flow from UN agencies (US$) of 2010 in Low income?
Make the answer very short. -7.66e+06. What is the difference between the Aid flow from UN agencies (US$) of 2007 and Aid flow from UN agencies (US$) of 2008 in Lower middle income?
Your answer should be compact. -2.99e+06. What is the difference between the Aid flow from UN agencies (US$) of 2007 and Aid flow from UN agencies (US$) of 2009 in Lower middle income?
Ensure brevity in your answer.  -4.44e+06. What is the difference between the Aid flow from UN agencies (US$) in 2007 and Aid flow from UN agencies (US$) in 2010 in Lower middle income?
Offer a terse response. -5.08e+06. What is the difference between the Aid flow from UN agencies (US$) of 2008 and Aid flow from UN agencies (US$) of 2009 in Lower middle income?
Your answer should be compact. -1.45e+06. What is the difference between the Aid flow from UN agencies (US$) in 2008 and Aid flow from UN agencies (US$) in 2010 in Lower middle income?
Offer a terse response. -2.09e+06. What is the difference between the Aid flow from UN agencies (US$) of 2009 and Aid flow from UN agencies (US$) of 2010 in Lower middle income?
Provide a succinct answer. -6.40e+05. What is the difference between the Aid flow from UN agencies (US$) of 2007 and Aid flow from UN agencies (US$) of 2008 in Sub-Saharan Africa (all income levels)?
Keep it short and to the point. -2.40e+07. What is the difference between the Aid flow from UN agencies (US$) in 2007 and Aid flow from UN agencies (US$) in 2009 in Sub-Saharan Africa (all income levels)?
Your answer should be compact. -3.12e+07. What is the difference between the Aid flow from UN agencies (US$) in 2007 and Aid flow from UN agencies (US$) in 2010 in Sub-Saharan Africa (all income levels)?
Provide a short and direct response. -3.17e+07. What is the difference between the Aid flow from UN agencies (US$) in 2008 and Aid flow from UN agencies (US$) in 2009 in Sub-Saharan Africa (all income levels)?
Provide a succinct answer. -7.17e+06. What is the difference between the Aid flow from UN agencies (US$) in 2008 and Aid flow from UN agencies (US$) in 2010 in Sub-Saharan Africa (all income levels)?
Your answer should be very brief. -7.64e+06. What is the difference between the Aid flow from UN agencies (US$) in 2009 and Aid flow from UN agencies (US$) in 2010 in Sub-Saharan Africa (all income levels)?
Make the answer very short. -4.70e+05. What is the ratio of the Aid flow from UN agencies (US$) in 2008 in Fragile and conflict affected situations to that in Heavily indebted poor countries?
Provide a succinct answer. 0.98. What is the ratio of the Aid flow from UN agencies (US$) in 2010 in Fragile and conflict affected situations to that in Heavily indebted poor countries?
Keep it short and to the point. 0.88. What is the ratio of the Aid flow from UN agencies (US$) in 2007 in Fragile and conflict affected situations to that in Least developed countries?
Offer a very short reply. 1.01. What is the ratio of the Aid flow from UN agencies (US$) of 2008 in Fragile and conflict affected situations to that in Least developed countries?
Your answer should be very brief. 1.08. What is the ratio of the Aid flow from UN agencies (US$) in 2009 in Fragile and conflict affected situations to that in Least developed countries?
Give a very brief answer. 1.08. What is the ratio of the Aid flow from UN agencies (US$) in 2010 in Fragile and conflict affected situations to that in Least developed countries?
Give a very brief answer. 0.79. What is the ratio of the Aid flow from UN agencies (US$) in 2007 in Fragile and conflict affected situations to that in Low income?
Give a very brief answer. 1.01. What is the ratio of the Aid flow from UN agencies (US$) in 2008 in Fragile and conflict affected situations to that in Low income?
Your answer should be compact. 1.07. What is the ratio of the Aid flow from UN agencies (US$) in 2009 in Fragile and conflict affected situations to that in Low income?
Your response must be concise. 1.08. What is the ratio of the Aid flow from UN agencies (US$) of 2010 in Fragile and conflict affected situations to that in Low income?
Your answer should be very brief. 0.84. What is the ratio of the Aid flow from UN agencies (US$) of 2007 in Fragile and conflict affected situations to that in Lower middle income?
Give a very brief answer. 159.17. What is the ratio of the Aid flow from UN agencies (US$) of 2008 in Fragile and conflict affected situations to that in Lower middle income?
Your response must be concise. 10.65. What is the ratio of the Aid flow from UN agencies (US$) in 2009 in Fragile and conflict affected situations to that in Lower middle income?
Provide a succinct answer. 9.14. What is the ratio of the Aid flow from UN agencies (US$) in 2010 in Fragile and conflict affected situations to that in Lower middle income?
Make the answer very short. 7.44. What is the ratio of the Aid flow from UN agencies (US$) in 2007 in Fragile and conflict affected situations to that in Sub-Saharan Africa (all income levels)?
Provide a succinct answer. 1. What is the ratio of the Aid flow from UN agencies (US$) in 2008 in Fragile and conflict affected situations to that in Sub-Saharan Africa (all income levels)?
Your response must be concise. 0.97. What is the ratio of the Aid flow from UN agencies (US$) in 2009 in Fragile and conflict affected situations to that in Sub-Saharan Africa (all income levels)?
Offer a very short reply. 1.01. What is the ratio of the Aid flow from UN agencies (US$) of 2010 in Fragile and conflict affected situations to that in Sub-Saharan Africa (all income levels)?
Your answer should be very brief. 0.93. What is the ratio of the Aid flow from UN agencies (US$) in 2008 in Heavily indebted poor countries to that in Least developed countries?
Your answer should be compact. 1.1. What is the ratio of the Aid flow from UN agencies (US$) in 2009 in Heavily indebted poor countries to that in Least developed countries?
Ensure brevity in your answer.  1.08. What is the ratio of the Aid flow from UN agencies (US$) of 2010 in Heavily indebted poor countries to that in Least developed countries?
Offer a very short reply. 0.9. What is the ratio of the Aid flow from UN agencies (US$) in 2007 in Heavily indebted poor countries to that in Low income?
Ensure brevity in your answer.  1.01. What is the ratio of the Aid flow from UN agencies (US$) in 2008 in Heavily indebted poor countries to that in Low income?
Your answer should be very brief. 1.09. What is the ratio of the Aid flow from UN agencies (US$) of 2009 in Heavily indebted poor countries to that in Low income?
Offer a terse response. 1.08. What is the ratio of the Aid flow from UN agencies (US$) of 2010 in Heavily indebted poor countries to that in Low income?
Keep it short and to the point. 0.95. What is the ratio of the Aid flow from UN agencies (US$) in 2007 in Heavily indebted poor countries to that in Lower middle income?
Your response must be concise. 159.17. What is the ratio of the Aid flow from UN agencies (US$) in 2008 in Heavily indebted poor countries to that in Lower middle income?
Provide a succinct answer. 10.88. What is the ratio of the Aid flow from UN agencies (US$) of 2009 in Heavily indebted poor countries to that in Lower middle income?
Keep it short and to the point. 9.14. What is the ratio of the Aid flow from UN agencies (US$) of 2010 in Heavily indebted poor countries to that in Lower middle income?
Your response must be concise. 8.46. What is the ratio of the Aid flow from UN agencies (US$) in 2008 in Heavily indebted poor countries to that in Sub-Saharan Africa (all income levels)?
Your answer should be very brief. 0.99. What is the ratio of the Aid flow from UN agencies (US$) in 2009 in Heavily indebted poor countries to that in Sub-Saharan Africa (all income levels)?
Offer a terse response. 1.01. What is the ratio of the Aid flow from UN agencies (US$) of 2010 in Heavily indebted poor countries to that in Sub-Saharan Africa (all income levels)?
Make the answer very short. 1.05. What is the ratio of the Aid flow from UN agencies (US$) in 2007 in Least developed countries to that in Low income?
Provide a short and direct response. 1. What is the ratio of the Aid flow from UN agencies (US$) in 2008 in Least developed countries to that in Low income?
Your answer should be compact. 0.99. What is the ratio of the Aid flow from UN agencies (US$) in 2010 in Least developed countries to that in Low income?
Offer a very short reply. 1.05. What is the ratio of the Aid flow from UN agencies (US$) of 2007 in Least developed countries to that in Lower middle income?
Provide a short and direct response. 158.17. What is the ratio of the Aid flow from UN agencies (US$) in 2008 in Least developed countries to that in Lower middle income?
Offer a very short reply. 9.88. What is the ratio of the Aid flow from UN agencies (US$) of 2009 in Least developed countries to that in Lower middle income?
Keep it short and to the point. 8.44. What is the ratio of the Aid flow from UN agencies (US$) of 2010 in Least developed countries to that in Lower middle income?
Your answer should be compact. 9.36. What is the ratio of the Aid flow from UN agencies (US$) of 2008 in Least developed countries to that in Sub-Saharan Africa (all income levels)?
Offer a terse response. 0.9. What is the ratio of the Aid flow from UN agencies (US$) of 2009 in Least developed countries to that in Sub-Saharan Africa (all income levels)?
Offer a very short reply. 0.93. What is the ratio of the Aid flow from UN agencies (US$) in 2010 in Least developed countries to that in Sub-Saharan Africa (all income levels)?
Make the answer very short. 1.17. What is the ratio of the Aid flow from UN agencies (US$) of 2007 in Low income to that in Lower middle income?
Ensure brevity in your answer.  158.17. What is the ratio of the Aid flow from UN agencies (US$) in 2008 in Low income to that in Lower middle income?
Provide a succinct answer. 9.98. What is the ratio of the Aid flow from UN agencies (US$) in 2009 in Low income to that in Lower middle income?
Provide a succinct answer. 8.48. What is the ratio of the Aid flow from UN agencies (US$) in 2010 in Low income to that in Lower middle income?
Your answer should be very brief. 8.91. What is the ratio of the Aid flow from UN agencies (US$) in 2008 in Low income to that in Sub-Saharan Africa (all income levels)?
Provide a succinct answer. 0.91. What is the ratio of the Aid flow from UN agencies (US$) of 2009 in Low income to that in Sub-Saharan Africa (all income levels)?
Provide a succinct answer. 0.94. What is the ratio of the Aid flow from UN agencies (US$) of 2010 in Low income to that in Sub-Saharan Africa (all income levels)?
Your response must be concise. 1.11. What is the ratio of the Aid flow from UN agencies (US$) in 2007 in Lower middle income to that in Sub-Saharan Africa (all income levels)?
Make the answer very short. 0.01. What is the ratio of the Aid flow from UN agencies (US$) in 2008 in Lower middle income to that in Sub-Saharan Africa (all income levels)?
Offer a terse response. 0.09. What is the ratio of the Aid flow from UN agencies (US$) of 2009 in Lower middle income to that in Sub-Saharan Africa (all income levels)?
Ensure brevity in your answer.  0.11. What is the ratio of the Aid flow from UN agencies (US$) of 2010 in Lower middle income to that in Sub-Saharan Africa (all income levels)?
Offer a very short reply. 0.12. What is the difference between the highest and the second highest Aid flow from UN agencies (US$) of 2007?
Provide a short and direct response. 0. What is the difference between the highest and the second highest Aid flow from UN agencies (US$) of 2008?
Your answer should be compact. 4.00e+05. What is the difference between the highest and the second highest Aid flow from UN agencies (US$) of 2010?
Your response must be concise. 2.32e+06. What is the difference between the highest and the lowest Aid flow from UN agencies (US$) of 2007?
Keep it short and to the point. 9.49e+06. What is the difference between the highest and the lowest Aid flow from UN agencies (US$) in 2008?
Your answer should be compact. 3.05e+07. What is the difference between the highest and the lowest Aid flow from UN agencies (US$) of 2009?
Your answer should be compact. 3.66e+07. What is the difference between the highest and the lowest Aid flow from UN agencies (US$) in 2010?
Give a very brief answer. 4.30e+07. 